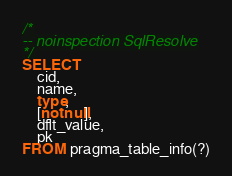Convert code to text. <code><loc_0><loc_0><loc_500><loc_500><_SQL_>/*
-- noinspection SqlResolve
*/
SELECT
    cid,
    name,
    type,
    [notnull],
    dflt_value,
    pk
FROM pragma_table_info(?)
</code> 